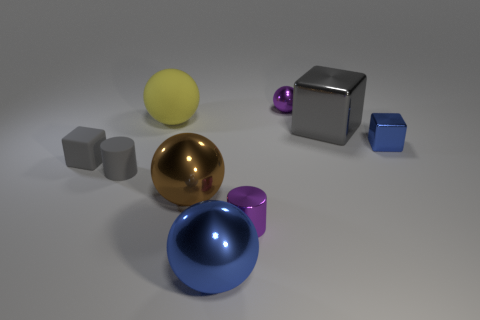What number of objects are either large cyan metal spheres or purple metallic objects?
Give a very brief answer. 2. What number of other objects are there of the same size as the blue block?
Provide a short and direct response. 4. Do the tiny matte cylinder and the matte block that is in front of the yellow matte object have the same color?
Provide a succinct answer. Yes. How many spheres are either gray shiny things or gray matte objects?
Your answer should be compact. 0. Are there any other things that are the same color as the small rubber cylinder?
Give a very brief answer. Yes. There is a purple object behind the gray metal thing that is behind the matte cylinder; what is it made of?
Ensure brevity in your answer.  Metal. Is the blue sphere made of the same material as the small cylinder that is in front of the large brown metallic ball?
Your response must be concise. Yes. What number of things are either brown objects that are in front of the big yellow object or shiny cylinders?
Keep it short and to the point. 2. Is there a large metallic object of the same color as the matte cylinder?
Your answer should be compact. Yes. There is a big blue thing; is it the same shape as the brown metallic thing in front of the gray matte block?
Provide a succinct answer. Yes. 